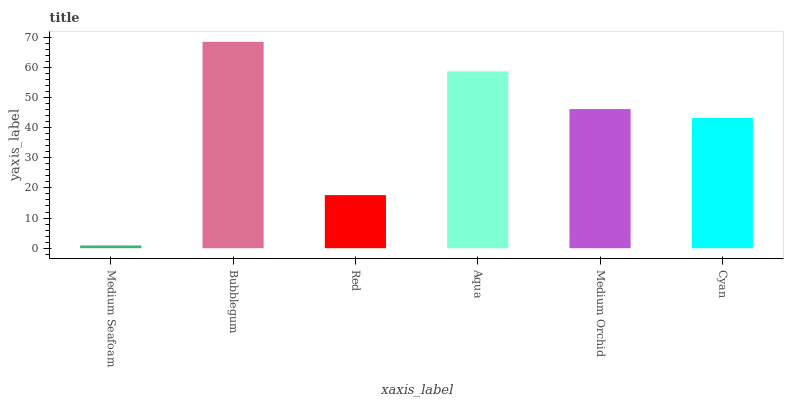Is Red the minimum?
Answer yes or no. No. Is Red the maximum?
Answer yes or no. No. Is Bubblegum greater than Red?
Answer yes or no. Yes. Is Red less than Bubblegum?
Answer yes or no. Yes. Is Red greater than Bubblegum?
Answer yes or no. No. Is Bubblegum less than Red?
Answer yes or no. No. Is Medium Orchid the high median?
Answer yes or no. Yes. Is Cyan the low median?
Answer yes or no. Yes. Is Red the high median?
Answer yes or no. No. Is Aqua the low median?
Answer yes or no. No. 